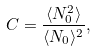<formula> <loc_0><loc_0><loc_500><loc_500>C = \frac { \langle N _ { 0 } ^ { 2 } \rangle } { \langle N _ { 0 } \rangle ^ { 2 } } ,</formula> 